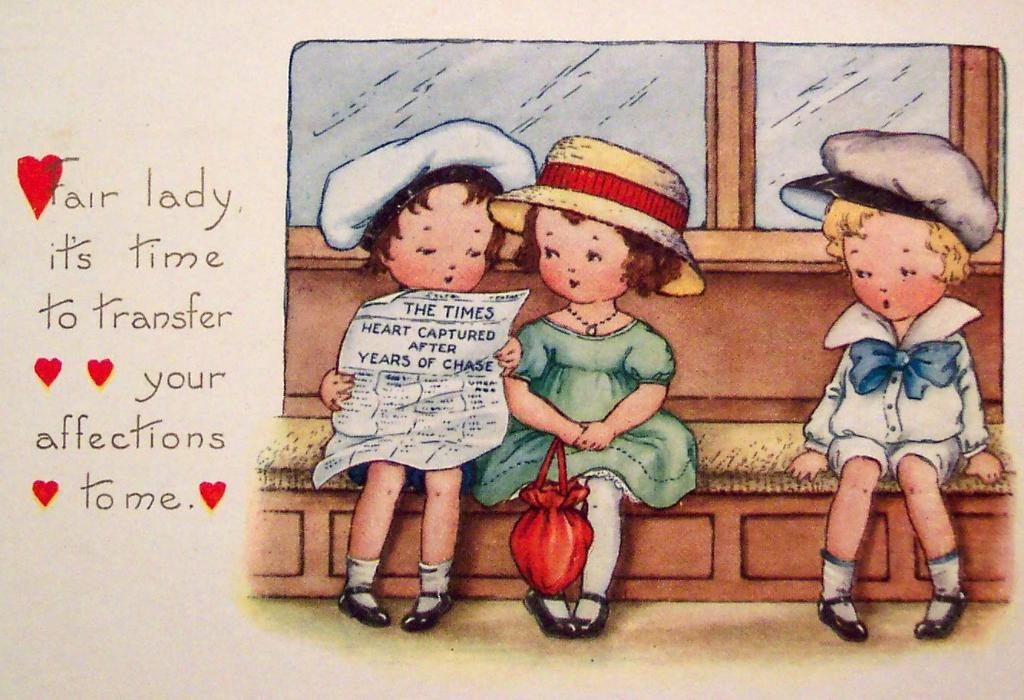How many kids are in the image? There are three kids in the image. What are the kids doing in the image? The kids are sitting on a bench. Can you describe the activity of one of the kids? One of the kids is reading a newspaper. What can be seen on the left side of the image? There is text on the left side of the image. What type of zipper can be seen on the tooth in the image? There is no zipper or tooth present in the image. How many pizzas are being eaten by the kids in the image? There are no pizzas visible in the image; the kids are sitting on a bench and one is reading a newspaper. 